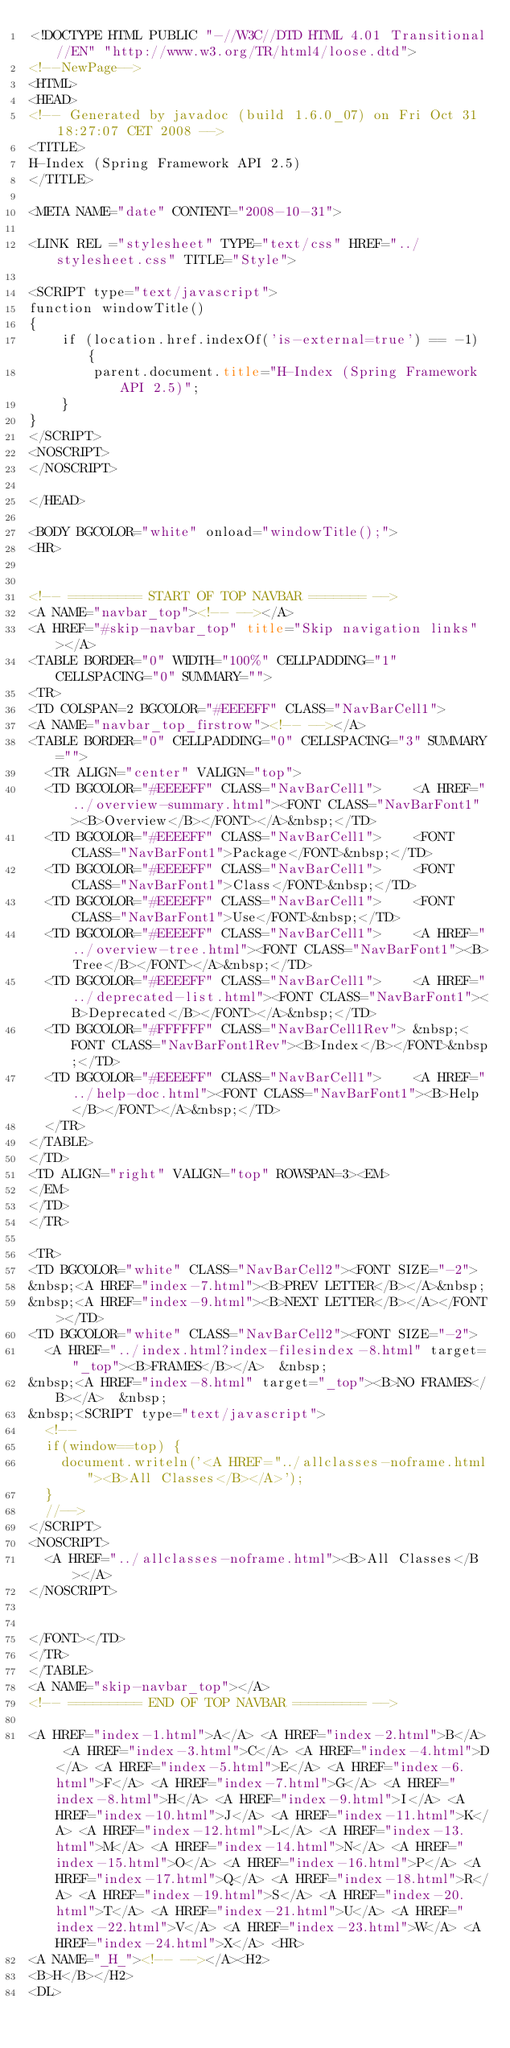Convert code to text. <code><loc_0><loc_0><loc_500><loc_500><_HTML_><!DOCTYPE HTML PUBLIC "-//W3C//DTD HTML 4.01 Transitional//EN" "http://www.w3.org/TR/html4/loose.dtd">
<!--NewPage-->
<HTML>
<HEAD>
<!-- Generated by javadoc (build 1.6.0_07) on Fri Oct 31 18:27:07 CET 2008 -->
<TITLE>
H-Index (Spring Framework API 2.5)
</TITLE>

<META NAME="date" CONTENT="2008-10-31">

<LINK REL ="stylesheet" TYPE="text/css" HREF="../stylesheet.css" TITLE="Style">

<SCRIPT type="text/javascript">
function windowTitle()
{
    if (location.href.indexOf('is-external=true') == -1) {
        parent.document.title="H-Index (Spring Framework API 2.5)";
    }
}
</SCRIPT>
<NOSCRIPT>
</NOSCRIPT>

</HEAD>

<BODY BGCOLOR="white" onload="windowTitle();">
<HR>


<!-- ========= START OF TOP NAVBAR ======= -->
<A NAME="navbar_top"><!-- --></A>
<A HREF="#skip-navbar_top" title="Skip navigation links"></A>
<TABLE BORDER="0" WIDTH="100%" CELLPADDING="1" CELLSPACING="0" SUMMARY="">
<TR>
<TD COLSPAN=2 BGCOLOR="#EEEEFF" CLASS="NavBarCell1">
<A NAME="navbar_top_firstrow"><!-- --></A>
<TABLE BORDER="0" CELLPADDING="0" CELLSPACING="3" SUMMARY="">
  <TR ALIGN="center" VALIGN="top">
  <TD BGCOLOR="#EEEEFF" CLASS="NavBarCell1">    <A HREF="../overview-summary.html"><FONT CLASS="NavBarFont1"><B>Overview</B></FONT></A>&nbsp;</TD>
  <TD BGCOLOR="#EEEEFF" CLASS="NavBarCell1">    <FONT CLASS="NavBarFont1">Package</FONT>&nbsp;</TD>
  <TD BGCOLOR="#EEEEFF" CLASS="NavBarCell1">    <FONT CLASS="NavBarFont1">Class</FONT>&nbsp;</TD>
  <TD BGCOLOR="#EEEEFF" CLASS="NavBarCell1">    <FONT CLASS="NavBarFont1">Use</FONT>&nbsp;</TD>
  <TD BGCOLOR="#EEEEFF" CLASS="NavBarCell1">    <A HREF="../overview-tree.html"><FONT CLASS="NavBarFont1"><B>Tree</B></FONT></A>&nbsp;</TD>
  <TD BGCOLOR="#EEEEFF" CLASS="NavBarCell1">    <A HREF="../deprecated-list.html"><FONT CLASS="NavBarFont1"><B>Deprecated</B></FONT></A>&nbsp;</TD>
  <TD BGCOLOR="#FFFFFF" CLASS="NavBarCell1Rev"> &nbsp;<FONT CLASS="NavBarFont1Rev"><B>Index</B></FONT>&nbsp;</TD>
  <TD BGCOLOR="#EEEEFF" CLASS="NavBarCell1">    <A HREF="../help-doc.html"><FONT CLASS="NavBarFont1"><B>Help</B></FONT></A>&nbsp;</TD>
  </TR>
</TABLE>
</TD>
<TD ALIGN="right" VALIGN="top" ROWSPAN=3><EM>
</EM>
</TD>
</TR>

<TR>
<TD BGCOLOR="white" CLASS="NavBarCell2"><FONT SIZE="-2">
&nbsp;<A HREF="index-7.html"><B>PREV LETTER</B></A>&nbsp;
&nbsp;<A HREF="index-9.html"><B>NEXT LETTER</B></A></FONT></TD>
<TD BGCOLOR="white" CLASS="NavBarCell2"><FONT SIZE="-2">
  <A HREF="../index.html?index-filesindex-8.html" target="_top"><B>FRAMES</B></A>  &nbsp;
&nbsp;<A HREF="index-8.html" target="_top"><B>NO FRAMES</B></A>  &nbsp;
&nbsp;<SCRIPT type="text/javascript">
  <!--
  if(window==top) {
    document.writeln('<A HREF="../allclasses-noframe.html"><B>All Classes</B></A>');
  }
  //-->
</SCRIPT>
<NOSCRIPT>
  <A HREF="../allclasses-noframe.html"><B>All Classes</B></A>
</NOSCRIPT>


</FONT></TD>
</TR>
</TABLE>
<A NAME="skip-navbar_top"></A>
<!-- ========= END OF TOP NAVBAR ========= -->

<A HREF="index-1.html">A</A> <A HREF="index-2.html">B</A> <A HREF="index-3.html">C</A> <A HREF="index-4.html">D</A> <A HREF="index-5.html">E</A> <A HREF="index-6.html">F</A> <A HREF="index-7.html">G</A> <A HREF="index-8.html">H</A> <A HREF="index-9.html">I</A> <A HREF="index-10.html">J</A> <A HREF="index-11.html">K</A> <A HREF="index-12.html">L</A> <A HREF="index-13.html">M</A> <A HREF="index-14.html">N</A> <A HREF="index-15.html">O</A> <A HREF="index-16.html">P</A> <A HREF="index-17.html">Q</A> <A HREF="index-18.html">R</A> <A HREF="index-19.html">S</A> <A HREF="index-20.html">T</A> <A HREF="index-21.html">U</A> <A HREF="index-22.html">V</A> <A HREF="index-23.html">W</A> <A HREF="index-24.html">X</A> <HR>
<A NAME="_H_"><!-- --></A><H2>
<B>H</B></H2>
<DL></code> 